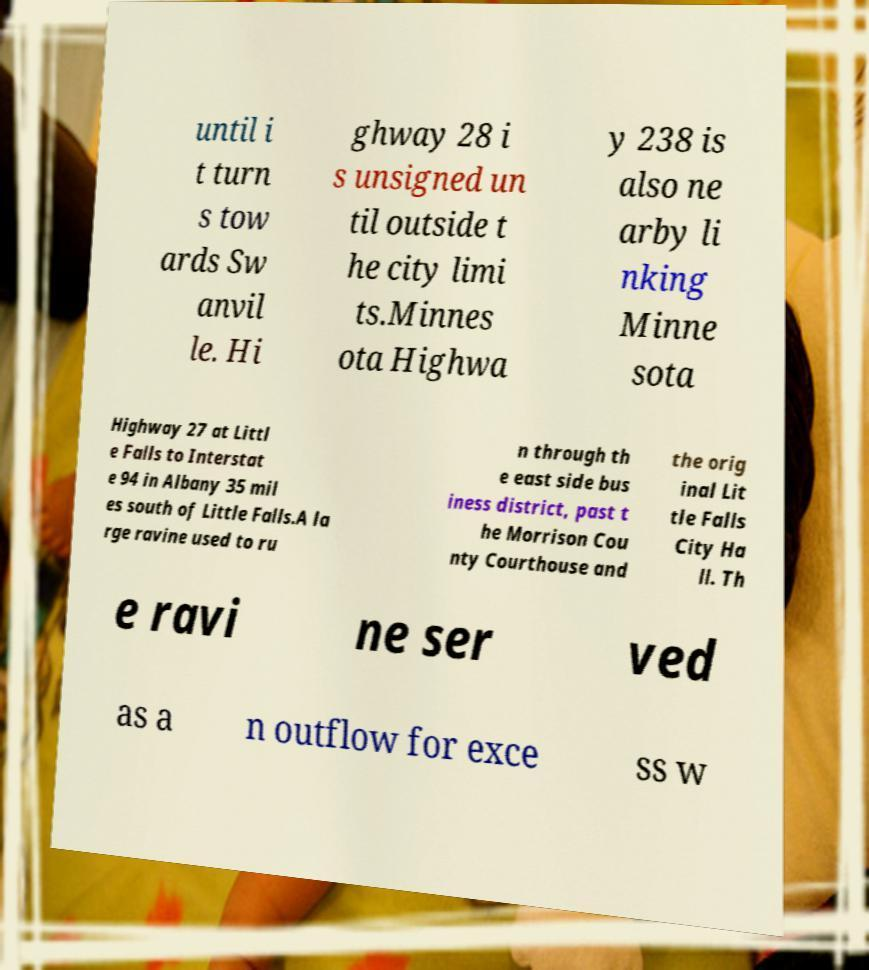Could you assist in decoding the text presented in this image and type it out clearly? until i t turn s tow ards Sw anvil le. Hi ghway 28 i s unsigned un til outside t he city limi ts.Minnes ota Highwa y 238 is also ne arby li nking Minne sota Highway 27 at Littl e Falls to Interstat e 94 in Albany 35 mil es south of Little Falls.A la rge ravine used to ru n through th e east side bus iness district, past t he Morrison Cou nty Courthouse and the orig inal Lit tle Falls City Ha ll. Th e ravi ne ser ved as a n outflow for exce ss w 